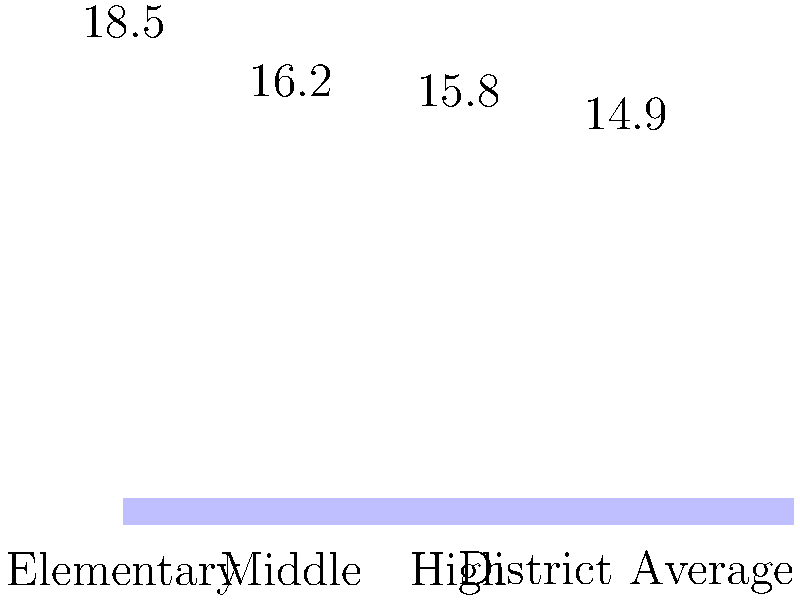Based on the bar graph showing student-to-teacher ratios in Mundelein schools, which level of education has the highest ratio, and how does it compare to the district average? To answer this question, we need to follow these steps:

1. Identify the highest student-to-teacher ratio:
   - Elementary: 18.5
   - Middle: 16.2
   - High: 15.8
   - District Average: 14.9

   The highest ratio is 18.5, which corresponds to the Elementary level.

2. Calculate the difference between the Elementary ratio and the district average:
   $18.5 - 14.9 = 3.6$

3. Calculate the percentage difference:
   $\frac{3.6}{14.9} \times 100\% \approx 24.16\%$

Therefore, the Elementary level has the highest student-to-teacher ratio, and it is approximately 24.16% higher than the district average.
Answer: Elementary; 24.16% higher than district average 